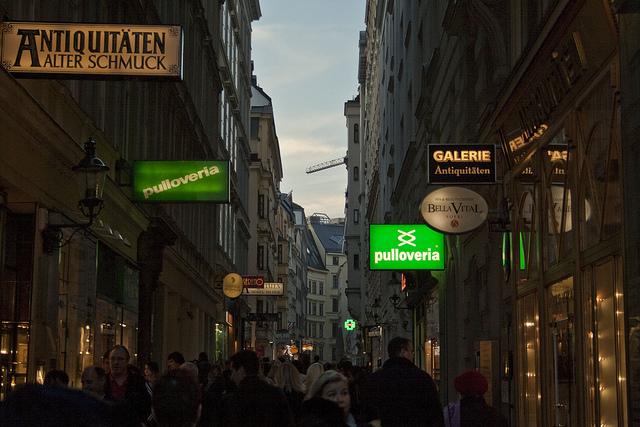What's that business on the other side of the street?
Be succinct. Pulloveria. What does the green sign say?
Concise answer only. Pulloveria. How many people are wearing a Red Hat?
Short answer required. 1. What is the scene in the photo?
Keep it brief. Street. 